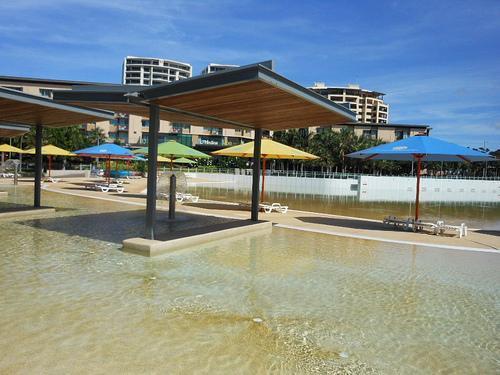How many umbrellas can be seen?
Give a very brief answer. 9. 